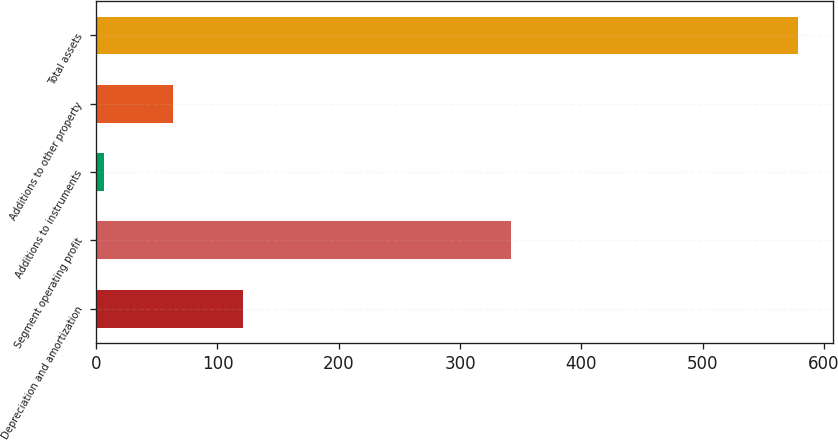<chart> <loc_0><loc_0><loc_500><loc_500><bar_chart><fcel>Depreciation and amortization<fcel>Segment operating profit<fcel>Additions to instruments<fcel>Additions to other property<fcel>Total assets<nl><fcel>120.86<fcel>342.3<fcel>6.5<fcel>63.68<fcel>578.3<nl></chart> 